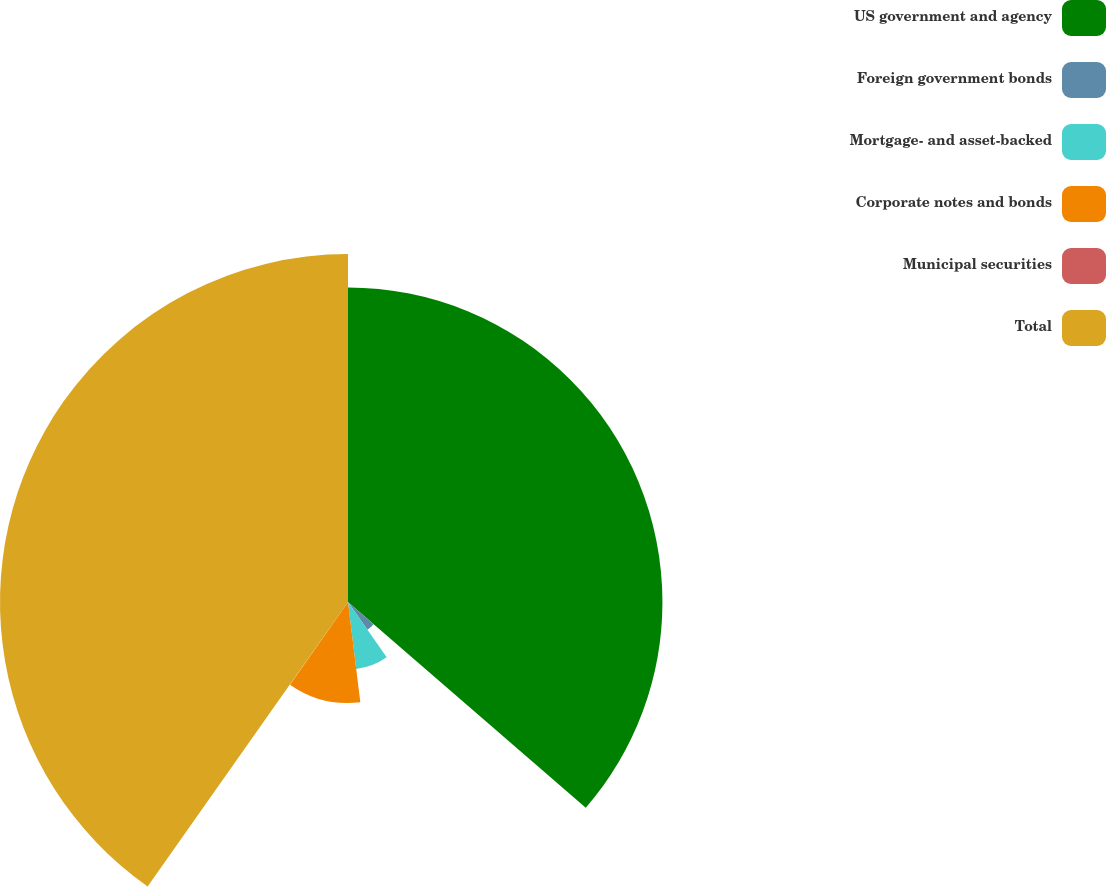Convert chart to OTSL. <chart><loc_0><loc_0><loc_500><loc_500><pie_chart><fcel>US government and agency<fcel>Foreign government bonds<fcel>Mortgage- and asset-backed<fcel>Corporate notes and bonds<fcel>Municipal securities<fcel>Total<nl><fcel>36.35%<fcel>3.91%<fcel>7.79%<fcel>11.68%<fcel>0.03%<fcel>40.23%<nl></chart> 